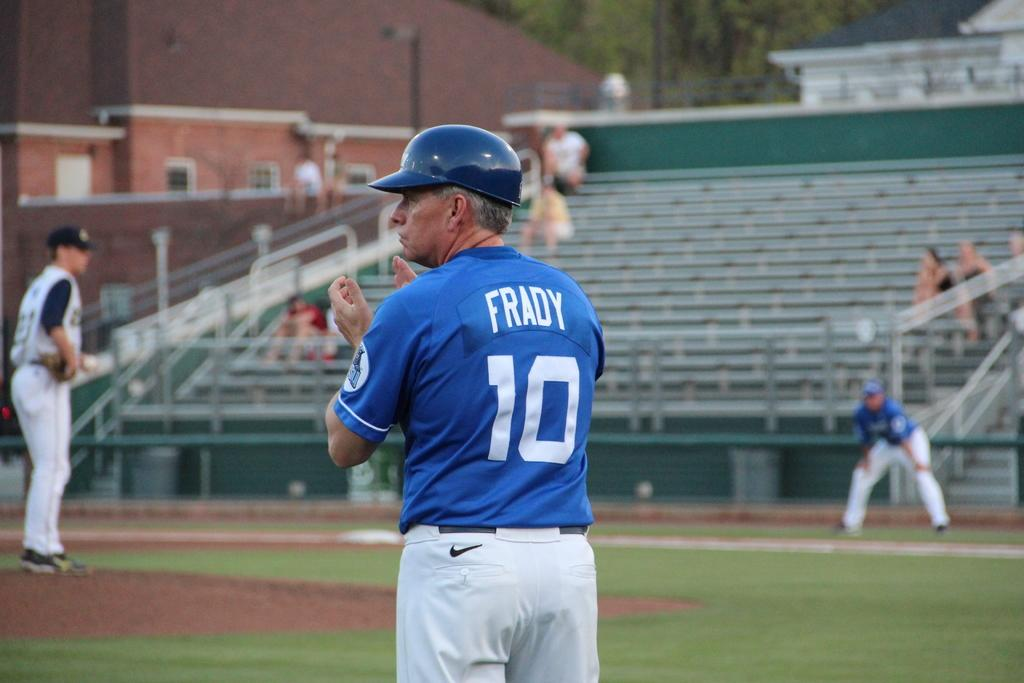<image>
Describe the image concisely. A baseball player wearing number ten and called Frady applauds as a sparse crowd watch. 